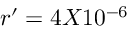Convert formula to latex. <formula><loc_0><loc_0><loc_500><loc_500>r ^ { \prime } = 4 X 1 0 ^ { - 6 }</formula> 